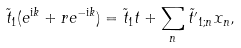Convert formula to latex. <formula><loc_0><loc_0><loc_500><loc_500>\tilde { t } _ { 1 } ( e ^ { \text {i} k } + r e ^ { - \text {i} k } ) = \tilde { t } _ { 1 } t + \sum _ { n } \tilde { t ^ { \prime } } _ { 1 ; n } x _ { n } ,</formula> 